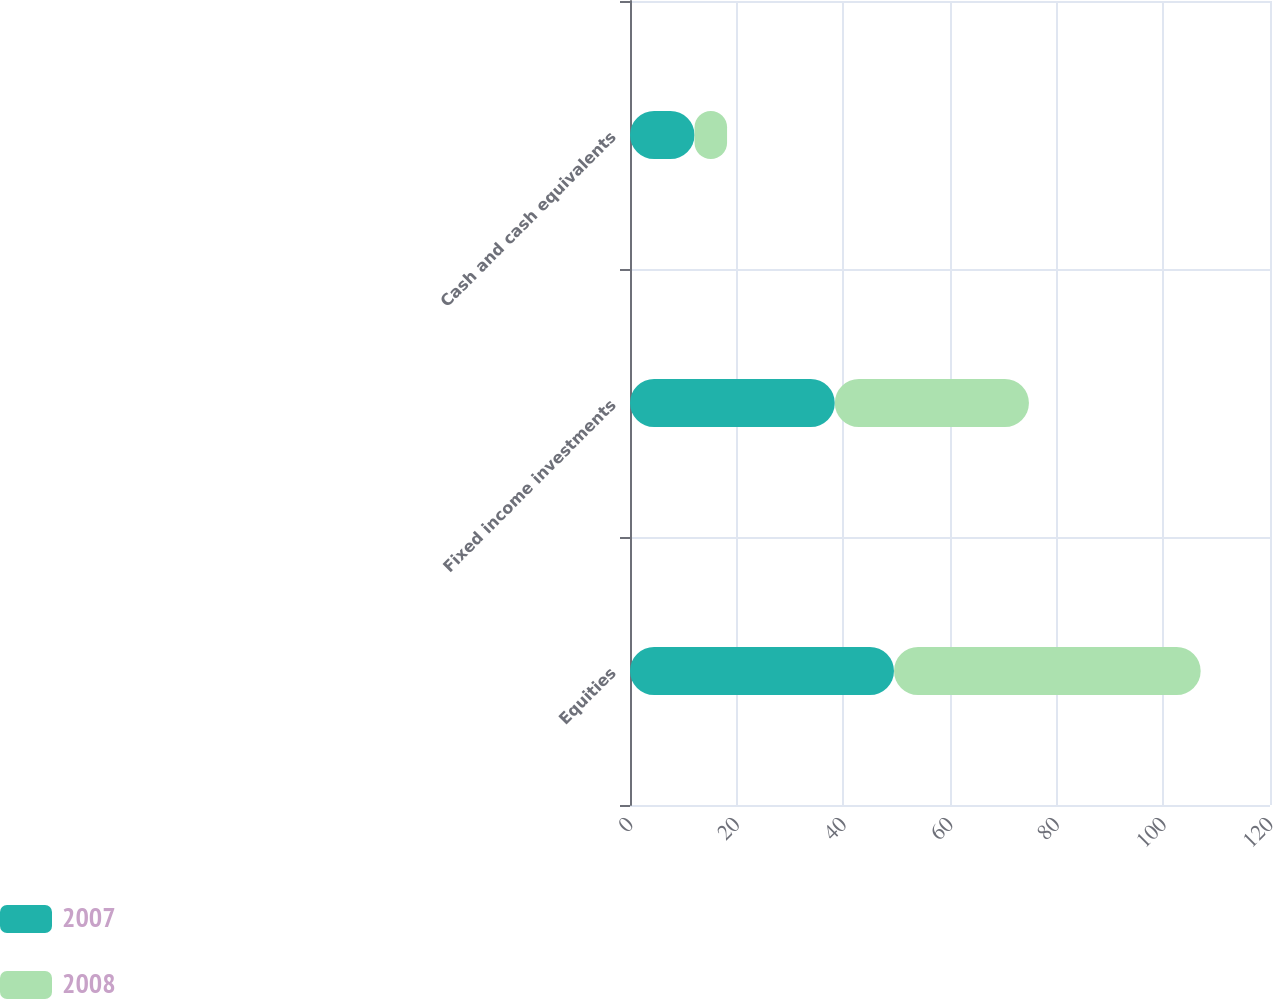Convert chart. <chart><loc_0><loc_0><loc_500><loc_500><stacked_bar_chart><ecel><fcel>Equities<fcel>Fixed income investments<fcel>Cash and cash equivalents<nl><fcel>2007<fcel>49.5<fcel>38.4<fcel>12.1<nl><fcel>2008<fcel>57.5<fcel>36.4<fcel>6.1<nl></chart> 